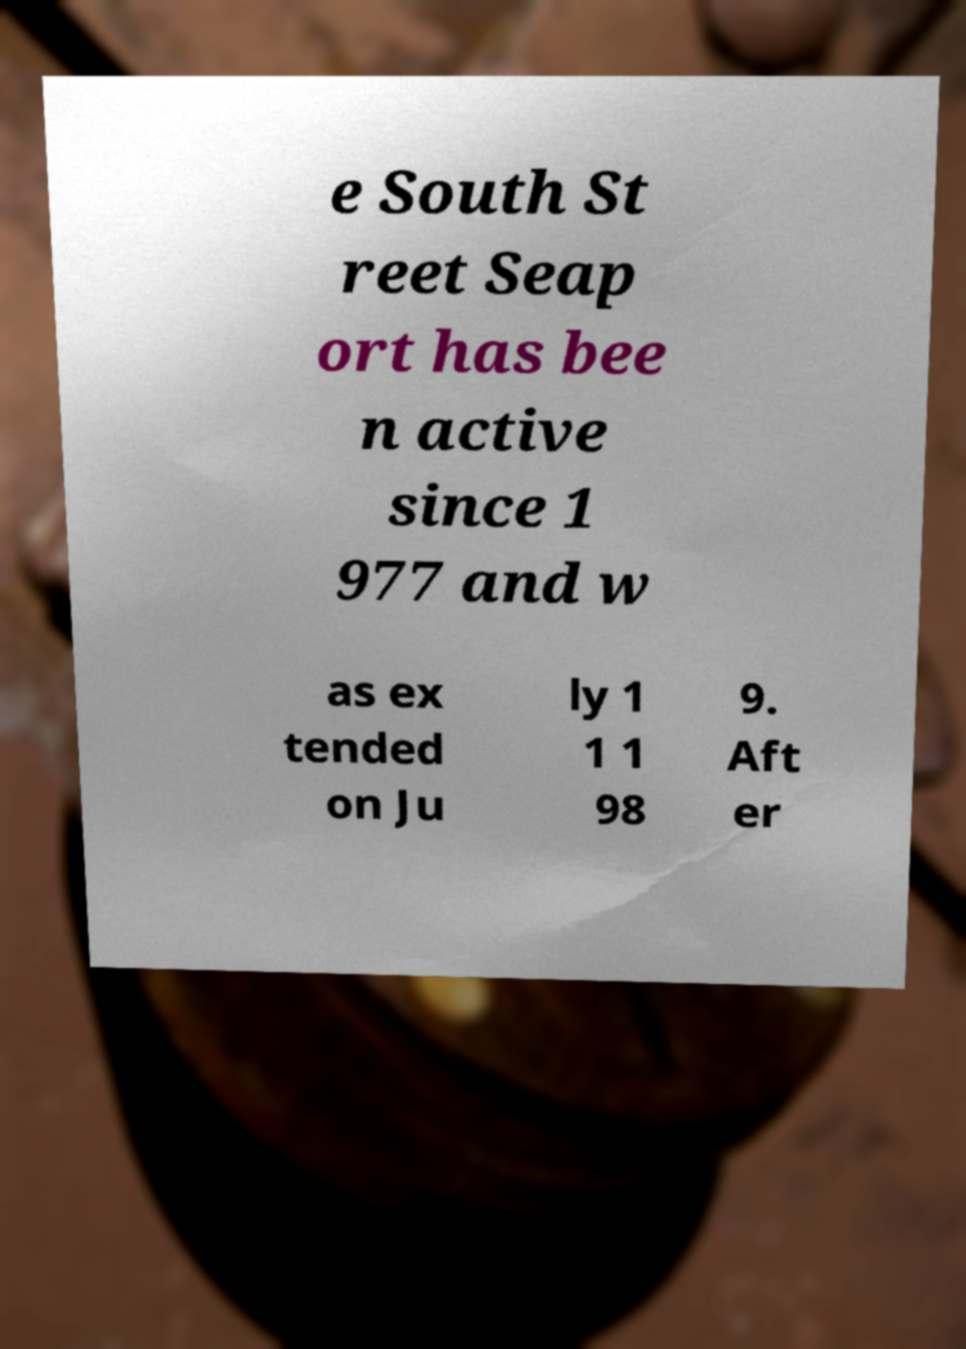Can you accurately transcribe the text from the provided image for me? e South St reet Seap ort has bee n active since 1 977 and w as ex tended on Ju ly 1 1 1 98 9. Aft er 